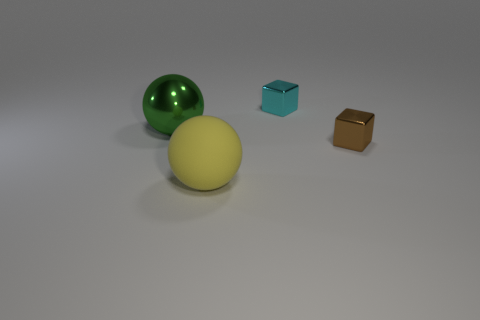Is there anything else that has the same material as the yellow object?
Your answer should be very brief. No. The object that is in front of the big metal sphere and behind the big matte ball is made of what material?
Provide a succinct answer. Metal. There is another green object that is the same shape as the rubber object; what material is it?
Keep it short and to the point. Metal. The large ball that is in front of the metal thing in front of the big green object on the left side of the big matte thing is what color?
Your response must be concise. Yellow. How many things are metallic spheres or tiny brown metal things?
Make the answer very short. 2. How many big yellow things are the same shape as the cyan metal object?
Offer a terse response. 0. Do the big green ball and the big object that is in front of the large green shiny object have the same material?
Your response must be concise. No. What is the size of the sphere that is made of the same material as the small brown cube?
Provide a succinct answer. Large. There is a thing on the left side of the matte sphere; how big is it?
Give a very brief answer. Large. How many yellow balls have the same size as the brown metal thing?
Your response must be concise. 0. 